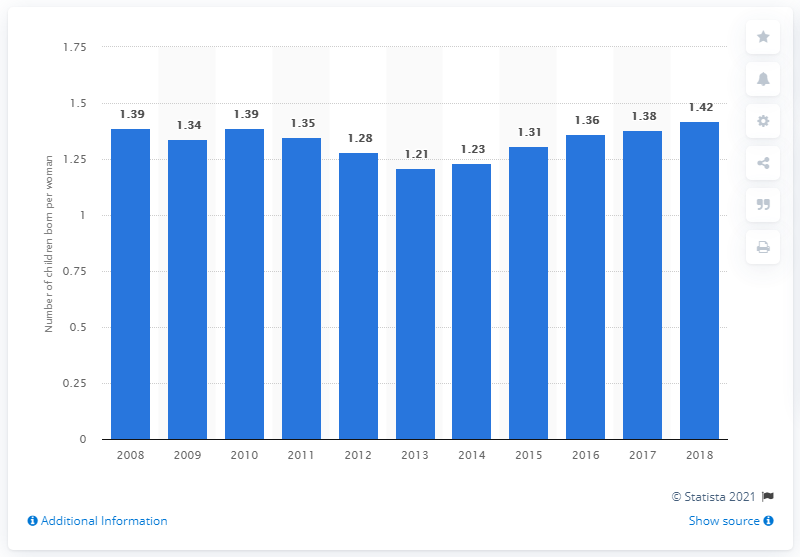What was the fertility rate in Portugal in 2018? In 2018, Portugal's fertility rate was 1.42 children per woman, reflecting a gradual increase after reaching a low point in earlier years, according to the data depicted in the chart. 